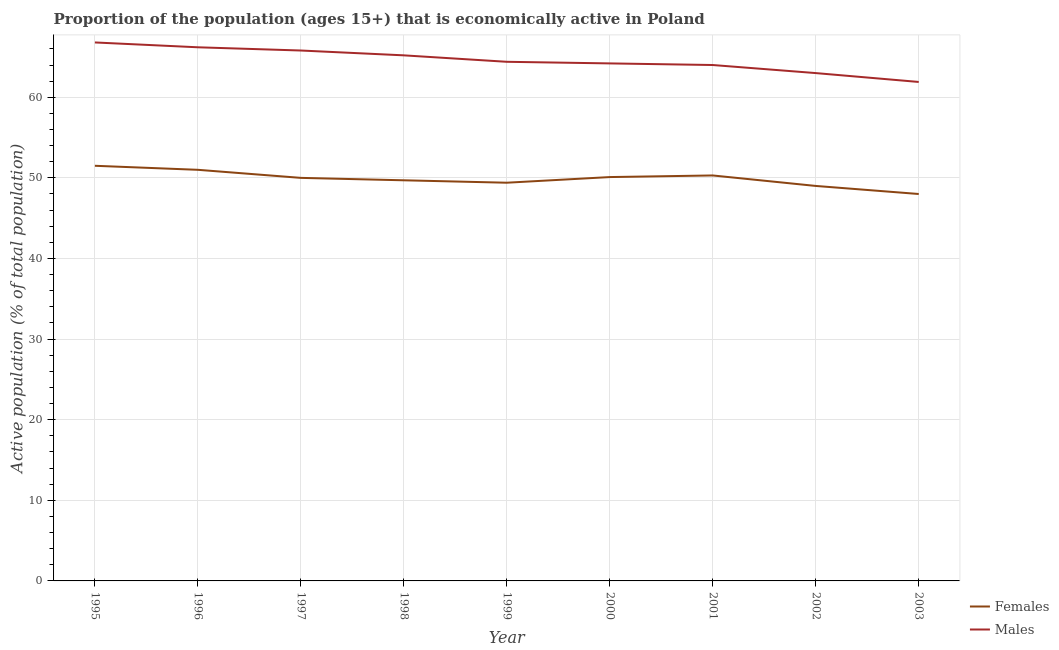How many different coloured lines are there?
Your answer should be very brief. 2. Does the line corresponding to percentage of economically active female population intersect with the line corresponding to percentage of economically active male population?
Ensure brevity in your answer.  No. What is the percentage of economically active male population in 1995?
Keep it short and to the point. 66.8. Across all years, what is the maximum percentage of economically active male population?
Provide a succinct answer. 66.8. Across all years, what is the minimum percentage of economically active male population?
Keep it short and to the point. 61.9. In which year was the percentage of economically active male population minimum?
Your response must be concise. 2003. What is the total percentage of economically active male population in the graph?
Offer a terse response. 581.5. What is the difference between the percentage of economically active male population in 2002 and that in 2003?
Give a very brief answer. 1.1. What is the difference between the percentage of economically active male population in 1998 and the percentage of economically active female population in 1995?
Your answer should be compact. 13.7. What is the average percentage of economically active male population per year?
Provide a short and direct response. 64.61. In the year 1995, what is the difference between the percentage of economically active male population and percentage of economically active female population?
Keep it short and to the point. 15.3. In how many years, is the percentage of economically active male population greater than 62 %?
Provide a short and direct response. 8. What is the ratio of the percentage of economically active male population in 2002 to that in 2003?
Keep it short and to the point. 1.02. What is the difference between the highest and the lowest percentage of economically active male population?
Your answer should be very brief. 4.9. In how many years, is the percentage of economically active female population greater than the average percentage of economically active female population taken over all years?
Provide a short and direct response. 5. Is the sum of the percentage of economically active female population in 1997 and 2000 greater than the maximum percentage of economically active male population across all years?
Your answer should be compact. Yes. Does the percentage of economically active female population monotonically increase over the years?
Your answer should be very brief. No. Is the percentage of economically active male population strictly greater than the percentage of economically active female population over the years?
Your answer should be very brief. Yes. Is the percentage of economically active female population strictly less than the percentage of economically active male population over the years?
Your response must be concise. Yes. How many lines are there?
Offer a terse response. 2. How many years are there in the graph?
Ensure brevity in your answer.  9. What is the difference between two consecutive major ticks on the Y-axis?
Give a very brief answer. 10. Are the values on the major ticks of Y-axis written in scientific E-notation?
Provide a succinct answer. No. Does the graph contain any zero values?
Give a very brief answer. No. Where does the legend appear in the graph?
Make the answer very short. Bottom right. How many legend labels are there?
Make the answer very short. 2. What is the title of the graph?
Make the answer very short. Proportion of the population (ages 15+) that is economically active in Poland. Does "Public credit registry" appear as one of the legend labels in the graph?
Provide a short and direct response. No. What is the label or title of the Y-axis?
Your response must be concise. Active population (% of total population). What is the Active population (% of total population) of Females in 1995?
Keep it short and to the point. 51.5. What is the Active population (% of total population) in Males in 1995?
Your answer should be compact. 66.8. What is the Active population (% of total population) of Females in 1996?
Keep it short and to the point. 51. What is the Active population (% of total population) in Males in 1996?
Provide a succinct answer. 66.2. What is the Active population (% of total population) of Males in 1997?
Offer a terse response. 65.8. What is the Active population (% of total population) in Females in 1998?
Your response must be concise. 49.7. What is the Active population (% of total population) of Males in 1998?
Your answer should be very brief. 65.2. What is the Active population (% of total population) in Females in 1999?
Offer a very short reply. 49.4. What is the Active population (% of total population) in Males in 1999?
Provide a succinct answer. 64.4. What is the Active population (% of total population) of Females in 2000?
Ensure brevity in your answer.  50.1. What is the Active population (% of total population) of Males in 2000?
Your answer should be very brief. 64.2. What is the Active population (% of total population) of Females in 2001?
Provide a succinct answer. 50.3. What is the Active population (% of total population) of Males in 2001?
Your answer should be compact. 64. What is the Active population (% of total population) in Females in 2002?
Make the answer very short. 49. What is the Active population (% of total population) in Females in 2003?
Make the answer very short. 48. What is the Active population (% of total population) in Males in 2003?
Your response must be concise. 61.9. Across all years, what is the maximum Active population (% of total population) in Females?
Ensure brevity in your answer.  51.5. Across all years, what is the maximum Active population (% of total population) in Males?
Provide a succinct answer. 66.8. Across all years, what is the minimum Active population (% of total population) in Females?
Your response must be concise. 48. Across all years, what is the minimum Active population (% of total population) in Males?
Give a very brief answer. 61.9. What is the total Active population (% of total population) of Females in the graph?
Ensure brevity in your answer.  449. What is the total Active population (% of total population) of Males in the graph?
Provide a succinct answer. 581.5. What is the difference between the Active population (% of total population) in Females in 1995 and that in 1996?
Offer a terse response. 0.5. What is the difference between the Active population (% of total population) of Males in 1995 and that in 1997?
Offer a very short reply. 1. What is the difference between the Active population (% of total population) in Females in 1995 and that in 1998?
Provide a succinct answer. 1.8. What is the difference between the Active population (% of total population) of Males in 1995 and that in 1998?
Your response must be concise. 1.6. What is the difference between the Active population (% of total population) of Males in 1995 and that in 1999?
Provide a short and direct response. 2.4. What is the difference between the Active population (% of total population) of Females in 1995 and that in 2000?
Your response must be concise. 1.4. What is the difference between the Active population (% of total population) in Males in 1995 and that in 2000?
Provide a succinct answer. 2.6. What is the difference between the Active population (% of total population) of Males in 1995 and that in 2001?
Your answer should be very brief. 2.8. What is the difference between the Active population (% of total population) of Females in 1995 and that in 2003?
Ensure brevity in your answer.  3.5. What is the difference between the Active population (% of total population) in Females in 1996 and that in 1997?
Make the answer very short. 1. What is the difference between the Active population (% of total population) of Males in 1996 and that in 1997?
Provide a succinct answer. 0.4. What is the difference between the Active population (% of total population) of Females in 1996 and that in 1998?
Make the answer very short. 1.3. What is the difference between the Active population (% of total population) of Males in 1996 and that in 2000?
Your answer should be compact. 2. What is the difference between the Active population (% of total population) of Females in 1996 and that in 2001?
Offer a very short reply. 0.7. What is the difference between the Active population (% of total population) in Males in 1996 and that in 2001?
Offer a very short reply. 2.2. What is the difference between the Active population (% of total population) in Females in 1996 and that in 2002?
Keep it short and to the point. 2. What is the difference between the Active population (% of total population) of Males in 1996 and that in 2002?
Your response must be concise. 3.2. What is the difference between the Active population (% of total population) in Males in 1996 and that in 2003?
Provide a succinct answer. 4.3. What is the difference between the Active population (% of total population) of Females in 1997 and that in 1999?
Offer a terse response. 0.6. What is the difference between the Active population (% of total population) of Males in 1997 and that in 1999?
Offer a terse response. 1.4. What is the difference between the Active population (% of total population) of Females in 1997 and that in 2000?
Your answer should be compact. -0.1. What is the difference between the Active population (% of total population) in Males in 1997 and that in 2000?
Provide a short and direct response. 1.6. What is the difference between the Active population (% of total population) in Females in 1997 and that in 2001?
Your answer should be compact. -0.3. What is the difference between the Active population (% of total population) of Females in 1997 and that in 2002?
Your answer should be compact. 1. What is the difference between the Active population (% of total population) in Males in 1997 and that in 2002?
Ensure brevity in your answer.  2.8. What is the difference between the Active population (% of total population) of Males in 1998 and that in 1999?
Your response must be concise. 0.8. What is the difference between the Active population (% of total population) of Males in 1998 and that in 2000?
Make the answer very short. 1. What is the difference between the Active population (% of total population) of Females in 1998 and that in 2001?
Your response must be concise. -0.6. What is the difference between the Active population (% of total population) of Males in 1999 and that in 2001?
Make the answer very short. 0.4. What is the difference between the Active population (% of total population) of Females in 1999 and that in 2002?
Your answer should be very brief. 0.4. What is the difference between the Active population (% of total population) of Males in 1999 and that in 2002?
Make the answer very short. 1.4. What is the difference between the Active population (% of total population) of Females in 1999 and that in 2003?
Keep it short and to the point. 1.4. What is the difference between the Active population (% of total population) of Males in 2000 and that in 2001?
Provide a succinct answer. 0.2. What is the difference between the Active population (% of total population) of Females in 2000 and that in 2002?
Your response must be concise. 1.1. What is the difference between the Active population (% of total population) of Females in 2000 and that in 2003?
Keep it short and to the point. 2.1. What is the difference between the Active population (% of total population) in Males in 2000 and that in 2003?
Give a very brief answer. 2.3. What is the difference between the Active population (% of total population) in Females in 2002 and that in 2003?
Ensure brevity in your answer.  1. What is the difference between the Active population (% of total population) of Females in 1995 and the Active population (% of total population) of Males in 1996?
Your answer should be very brief. -14.7. What is the difference between the Active population (% of total population) in Females in 1995 and the Active population (% of total population) in Males in 1997?
Your answer should be very brief. -14.3. What is the difference between the Active population (% of total population) in Females in 1995 and the Active population (% of total population) in Males in 1998?
Keep it short and to the point. -13.7. What is the difference between the Active population (% of total population) of Females in 1995 and the Active population (% of total population) of Males in 2000?
Your response must be concise. -12.7. What is the difference between the Active population (% of total population) in Females in 1995 and the Active population (% of total population) in Males in 2003?
Your answer should be compact. -10.4. What is the difference between the Active population (% of total population) in Females in 1996 and the Active population (% of total population) in Males in 1997?
Your answer should be compact. -14.8. What is the difference between the Active population (% of total population) in Females in 1996 and the Active population (% of total population) in Males in 1998?
Provide a succinct answer. -14.2. What is the difference between the Active population (% of total population) in Females in 1996 and the Active population (% of total population) in Males in 2002?
Give a very brief answer. -12. What is the difference between the Active population (% of total population) of Females in 1997 and the Active population (% of total population) of Males in 1998?
Ensure brevity in your answer.  -15.2. What is the difference between the Active population (% of total population) in Females in 1997 and the Active population (% of total population) in Males in 1999?
Offer a very short reply. -14.4. What is the difference between the Active population (% of total population) in Females in 1997 and the Active population (% of total population) in Males in 2000?
Offer a terse response. -14.2. What is the difference between the Active population (% of total population) in Females in 1997 and the Active population (% of total population) in Males in 2002?
Give a very brief answer. -13. What is the difference between the Active population (% of total population) of Females in 1998 and the Active population (% of total population) of Males in 1999?
Ensure brevity in your answer.  -14.7. What is the difference between the Active population (% of total population) in Females in 1998 and the Active population (% of total population) in Males in 2000?
Provide a short and direct response. -14.5. What is the difference between the Active population (% of total population) of Females in 1998 and the Active population (% of total population) of Males in 2001?
Make the answer very short. -14.3. What is the difference between the Active population (% of total population) of Females in 1998 and the Active population (% of total population) of Males in 2002?
Your answer should be compact. -13.3. What is the difference between the Active population (% of total population) of Females in 1999 and the Active population (% of total population) of Males in 2000?
Offer a terse response. -14.8. What is the difference between the Active population (% of total population) of Females in 1999 and the Active population (% of total population) of Males in 2001?
Offer a terse response. -14.6. What is the difference between the Active population (% of total population) of Females in 1999 and the Active population (% of total population) of Males in 2003?
Offer a terse response. -12.5. What is the difference between the Active population (% of total population) of Females in 2002 and the Active population (% of total population) of Males in 2003?
Ensure brevity in your answer.  -12.9. What is the average Active population (% of total population) in Females per year?
Give a very brief answer. 49.89. What is the average Active population (% of total population) of Males per year?
Give a very brief answer. 64.61. In the year 1995, what is the difference between the Active population (% of total population) in Females and Active population (% of total population) in Males?
Make the answer very short. -15.3. In the year 1996, what is the difference between the Active population (% of total population) in Females and Active population (% of total population) in Males?
Your answer should be compact. -15.2. In the year 1997, what is the difference between the Active population (% of total population) in Females and Active population (% of total population) in Males?
Offer a very short reply. -15.8. In the year 1998, what is the difference between the Active population (% of total population) in Females and Active population (% of total population) in Males?
Make the answer very short. -15.5. In the year 1999, what is the difference between the Active population (% of total population) in Females and Active population (% of total population) in Males?
Provide a short and direct response. -15. In the year 2000, what is the difference between the Active population (% of total population) in Females and Active population (% of total population) in Males?
Offer a very short reply. -14.1. In the year 2001, what is the difference between the Active population (% of total population) of Females and Active population (% of total population) of Males?
Your answer should be very brief. -13.7. In the year 2003, what is the difference between the Active population (% of total population) of Females and Active population (% of total population) of Males?
Your answer should be compact. -13.9. What is the ratio of the Active population (% of total population) of Females in 1995 to that in 1996?
Your response must be concise. 1.01. What is the ratio of the Active population (% of total population) of Males in 1995 to that in 1996?
Your answer should be compact. 1.01. What is the ratio of the Active population (% of total population) of Females in 1995 to that in 1997?
Give a very brief answer. 1.03. What is the ratio of the Active population (% of total population) of Males in 1995 to that in 1997?
Ensure brevity in your answer.  1.02. What is the ratio of the Active population (% of total population) of Females in 1995 to that in 1998?
Your response must be concise. 1.04. What is the ratio of the Active population (% of total population) of Males in 1995 to that in 1998?
Provide a succinct answer. 1.02. What is the ratio of the Active population (% of total population) of Females in 1995 to that in 1999?
Your response must be concise. 1.04. What is the ratio of the Active population (% of total population) in Males in 1995 to that in 1999?
Offer a terse response. 1.04. What is the ratio of the Active population (% of total population) of Females in 1995 to that in 2000?
Keep it short and to the point. 1.03. What is the ratio of the Active population (% of total population) of Males in 1995 to that in 2000?
Your response must be concise. 1.04. What is the ratio of the Active population (% of total population) of Females in 1995 to that in 2001?
Give a very brief answer. 1.02. What is the ratio of the Active population (% of total population) of Males in 1995 to that in 2001?
Offer a very short reply. 1.04. What is the ratio of the Active population (% of total population) in Females in 1995 to that in 2002?
Your answer should be compact. 1.05. What is the ratio of the Active population (% of total population) in Males in 1995 to that in 2002?
Keep it short and to the point. 1.06. What is the ratio of the Active population (% of total population) of Females in 1995 to that in 2003?
Your answer should be compact. 1.07. What is the ratio of the Active population (% of total population) in Males in 1995 to that in 2003?
Provide a short and direct response. 1.08. What is the ratio of the Active population (% of total population) in Females in 1996 to that in 1997?
Your response must be concise. 1.02. What is the ratio of the Active population (% of total population) in Males in 1996 to that in 1997?
Ensure brevity in your answer.  1.01. What is the ratio of the Active population (% of total population) in Females in 1996 to that in 1998?
Make the answer very short. 1.03. What is the ratio of the Active population (% of total population) of Males in 1996 to that in 1998?
Give a very brief answer. 1.02. What is the ratio of the Active population (% of total population) in Females in 1996 to that in 1999?
Give a very brief answer. 1.03. What is the ratio of the Active population (% of total population) in Males in 1996 to that in 1999?
Offer a very short reply. 1.03. What is the ratio of the Active population (% of total population) in Females in 1996 to that in 2000?
Offer a very short reply. 1.02. What is the ratio of the Active population (% of total population) in Males in 1996 to that in 2000?
Your answer should be very brief. 1.03. What is the ratio of the Active population (% of total population) in Females in 1996 to that in 2001?
Offer a very short reply. 1.01. What is the ratio of the Active population (% of total population) of Males in 1996 to that in 2001?
Your answer should be very brief. 1.03. What is the ratio of the Active population (% of total population) of Females in 1996 to that in 2002?
Offer a terse response. 1.04. What is the ratio of the Active population (% of total population) in Males in 1996 to that in 2002?
Offer a terse response. 1.05. What is the ratio of the Active population (% of total population) in Females in 1996 to that in 2003?
Your answer should be very brief. 1.06. What is the ratio of the Active population (% of total population) in Males in 1996 to that in 2003?
Make the answer very short. 1.07. What is the ratio of the Active population (% of total population) in Males in 1997 to that in 1998?
Provide a succinct answer. 1.01. What is the ratio of the Active population (% of total population) in Females in 1997 to that in 1999?
Offer a very short reply. 1.01. What is the ratio of the Active population (% of total population) of Males in 1997 to that in 1999?
Offer a terse response. 1.02. What is the ratio of the Active population (% of total population) of Males in 1997 to that in 2000?
Offer a very short reply. 1.02. What is the ratio of the Active population (% of total population) in Females in 1997 to that in 2001?
Keep it short and to the point. 0.99. What is the ratio of the Active population (% of total population) in Males in 1997 to that in 2001?
Ensure brevity in your answer.  1.03. What is the ratio of the Active population (% of total population) of Females in 1997 to that in 2002?
Offer a very short reply. 1.02. What is the ratio of the Active population (% of total population) in Males in 1997 to that in 2002?
Provide a succinct answer. 1.04. What is the ratio of the Active population (% of total population) of Females in 1997 to that in 2003?
Provide a succinct answer. 1.04. What is the ratio of the Active population (% of total population) of Males in 1997 to that in 2003?
Your answer should be very brief. 1.06. What is the ratio of the Active population (% of total population) of Females in 1998 to that in 1999?
Your answer should be compact. 1.01. What is the ratio of the Active population (% of total population) of Males in 1998 to that in 1999?
Your answer should be compact. 1.01. What is the ratio of the Active population (% of total population) of Males in 1998 to that in 2000?
Make the answer very short. 1.02. What is the ratio of the Active population (% of total population) in Males in 1998 to that in 2001?
Give a very brief answer. 1.02. What is the ratio of the Active population (% of total population) in Females in 1998 to that in 2002?
Your response must be concise. 1.01. What is the ratio of the Active population (% of total population) of Males in 1998 to that in 2002?
Offer a terse response. 1.03. What is the ratio of the Active population (% of total population) in Females in 1998 to that in 2003?
Your answer should be very brief. 1.04. What is the ratio of the Active population (% of total population) of Males in 1998 to that in 2003?
Offer a very short reply. 1.05. What is the ratio of the Active population (% of total population) of Males in 1999 to that in 2000?
Give a very brief answer. 1. What is the ratio of the Active population (% of total population) of Females in 1999 to that in 2001?
Give a very brief answer. 0.98. What is the ratio of the Active population (% of total population) in Males in 1999 to that in 2001?
Provide a succinct answer. 1.01. What is the ratio of the Active population (% of total population) of Females in 1999 to that in 2002?
Make the answer very short. 1.01. What is the ratio of the Active population (% of total population) of Males in 1999 to that in 2002?
Offer a very short reply. 1.02. What is the ratio of the Active population (% of total population) in Females in 1999 to that in 2003?
Ensure brevity in your answer.  1.03. What is the ratio of the Active population (% of total population) in Males in 1999 to that in 2003?
Provide a succinct answer. 1.04. What is the ratio of the Active population (% of total population) in Females in 2000 to that in 2001?
Your response must be concise. 1. What is the ratio of the Active population (% of total population) in Males in 2000 to that in 2001?
Keep it short and to the point. 1. What is the ratio of the Active population (% of total population) of Females in 2000 to that in 2002?
Offer a very short reply. 1.02. What is the ratio of the Active population (% of total population) in Females in 2000 to that in 2003?
Offer a very short reply. 1.04. What is the ratio of the Active population (% of total population) in Males in 2000 to that in 2003?
Your answer should be compact. 1.04. What is the ratio of the Active population (% of total population) in Females in 2001 to that in 2002?
Your answer should be compact. 1.03. What is the ratio of the Active population (% of total population) in Males in 2001 to that in 2002?
Your answer should be compact. 1.02. What is the ratio of the Active population (% of total population) in Females in 2001 to that in 2003?
Your answer should be very brief. 1.05. What is the ratio of the Active population (% of total population) of Males in 2001 to that in 2003?
Your answer should be compact. 1.03. What is the ratio of the Active population (% of total population) of Females in 2002 to that in 2003?
Keep it short and to the point. 1.02. What is the ratio of the Active population (% of total population) of Males in 2002 to that in 2003?
Provide a short and direct response. 1.02. What is the difference between the highest and the second highest Active population (% of total population) of Females?
Provide a short and direct response. 0.5. What is the difference between the highest and the second highest Active population (% of total population) of Males?
Ensure brevity in your answer.  0.6. What is the difference between the highest and the lowest Active population (% of total population) in Females?
Offer a terse response. 3.5. 